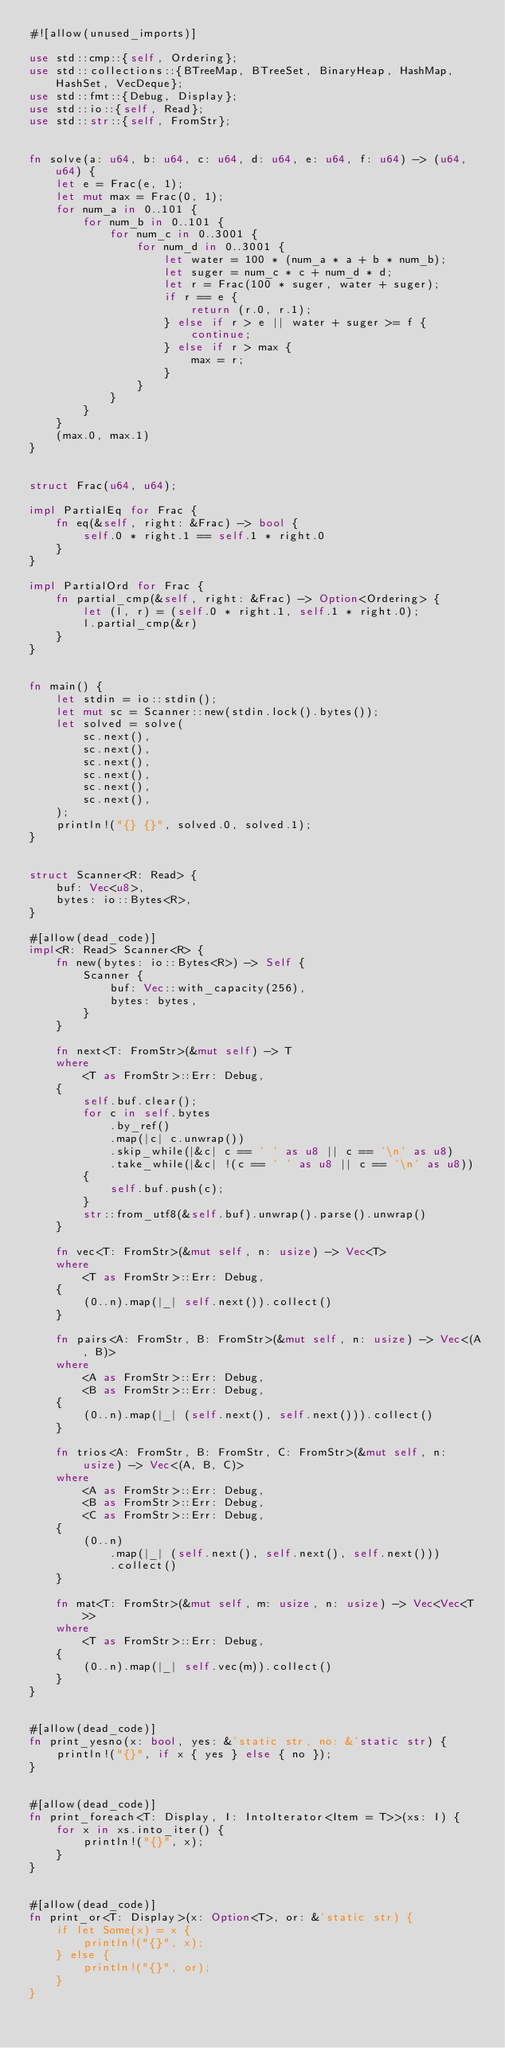<code> <loc_0><loc_0><loc_500><loc_500><_Rust_>#![allow(unused_imports)]

use std::cmp::{self, Ordering};
use std::collections::{BTreeMap, BTreeSet, BinaryHeap, HashMap, HashSet, VecDeque};
use std::fmt::{Debug, Display};
use std::io::{self, Read};
use std::str::{self, FromStr};


fn solve(a: u64, b: u64, c: u64, d: u64, e: u64, f: u64) -> (u64, u64) {
    let e = Frac(e, 1);
    let mut max = Frac(0, 1);
    for num_a in 0..101 {
        for num_b in 0..101 {
            for num_c in 0..3001 {
                for num_d in 0..3001 {
                    let water = 100 * (num_a * a + b * num_b);
                    let suger = num_c * c + num_d * d;
                    let r = Frac(100 * suger, water + suger);
                    if r == e {
                        return (r.0, r.1);
                    } else if r > e || water + suger >= f {
                        continue;
                    } else if r > max {
                        max = r;
                    }
                }
            }
        }
    }
    (max.0, max.1)
}


struct Frac(u64, u64);

impl PartialEq for Frac {
    fn eq(&self, right: &Frac) -> bool {
        self.0 * right.1 == self.1 * right.0
    }
}

impl PartialOrd for Frac {
    fn partial_cmp(&self, right: &Frac) -> Option<Ordering> {
        let (l, r) = (self.0 * right.1, self.1 * right.0);
        l.partial_cmp(&r)
    }
}


fn main() {
    let stdin = io::stdin();
    let mut sc = Scanner::new(stdin.lock().bytes());
    let solved = solve(
        sc.next(),
        sc.next(),
        sc.next(),
        sc.next(),
        sc.next(),
        sc.next(),
    );
    println!("{} {}", solved.0, solved.1);
}


struct Scanner<R: Read> {
    buf: Vec<u8>,
    bytes: io::Bytes<R>,
}

#[allow(dead_code)]
impl<R: Read> Scanner<R> {
    fn new(bytes: io::Bytes<R>) -> Self {
        Scanner {
            buf: Vec::with_capacity(256),
            bytes: bytes,
        }
    }

    fn next<T: FromStr>(&mut self) -> T
    where
        <T as FromStr>::Err: Debug,
    {
        self.buf.clear();
        for c in self.bytes
            .by_ref()
            .map(|c| c.unwrap())
            .skip_while(|&c| c == ' ' as u8 || c == '\n' as u8)
            .take_while(|&c| !(c == ' ' as u8 || c == '\n' as u8))
        {
            self.buf.push(c);
        }
        str::from_utf8(&self.buf).unwrap().parse().unwrap()
    }

    fn vec<T: FromStr>(&mut self, n: usize) -> Vec<T>
    where
        <T as FromStr>::Err: Debug,
    {
        (0..n).map(|_| self.next()).collect()
    }

    fn pairs<A: FromStr, B: FromStr>(&mut self, n: usize) -> Vec<(A, B)>
    where
        <A as FromStr>::Err: Debug,
        <B as FromStr>::Err: Debug,
    {
        (0..n).map(|_| (self.next(), self.next())).collect()
    }

    fn trios<A: FromStr, B: FromStr, C: FromStr>(&mut self, n: usize) -> Vec<(A, B, C)>
    where
        <A as FromStr>::Err: Debug,
        <B as FromStr>::Err: Debug,
        <C as FromStr>::Err: Debug,
    {
        (0..n)
            .map(|_| (self.next(), self.next(), self.next()))
            .collect()
    }

    fn mat<T: FromStr>(&mut self, m: usize, n: usize) -> Vec<Vec<T>>
    where
        <T as FromStr>::Err: Debug,
    {
        (0..n).map(|_| self.vec(m)).collect()
    }
}


#[allow(dead_code)]
fn print_yesno(x: bool, yes: &'static str, no: &'static str) {
    println!("{}", if x { yes } else { no });
}


#[allow(dead_code)]
fn print_foreach<T: Display, I: IntoIterator<Item = T>>(xs: I) {
    for x in xs.into_iter() {
        println!("{}", x);
    }
}


#[allow(dead_code)]
fn print_or<T: Display>(x: Option<T>, or: &'static str) {
    if let Some(x) = x {
        println!("{}", x);
    } else {
        println!("{}", or);
    }
}
</code> 